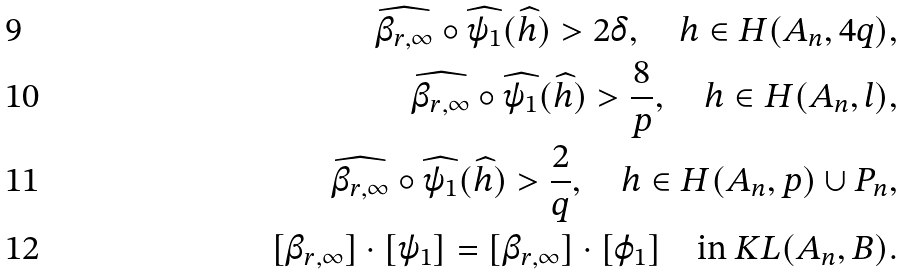<formula> <loc_0><loc_0><loc_500><loc_500>\widehat { \beta _ { r , \infty } } \circ \widehat { \psi _ { 1 } } ( \widehat { h } ) > 2 \delta , \quad h \in H ( A _ { n } , 4 q ) , \\ \widehat { \beta _ { r , \infty } } \circ \widehat { \psi _ { 1 } } ( \widehat { h } ) > \frac { 8 } { p } , \quad h \in H ( A _ { n } , l ) , \\ \widehat { \beta _ { r , \infty } } \circ \widehat { \psi _ { 1 } } ( \widehat { h } ) > \frac { 2 } { q } , \quad h \in H ( A _ { n } , p ) \cup P _ { n } , \\ [ \beta _ { r , \infty } ] \cdot [ \psi _ { 1 } ] = [ \beta _ { r , \infty } ] \cdot [ \varphi _ { 1 } ] \quad \text {in} \ K L ( A _ { n } , B ) .</formula> 